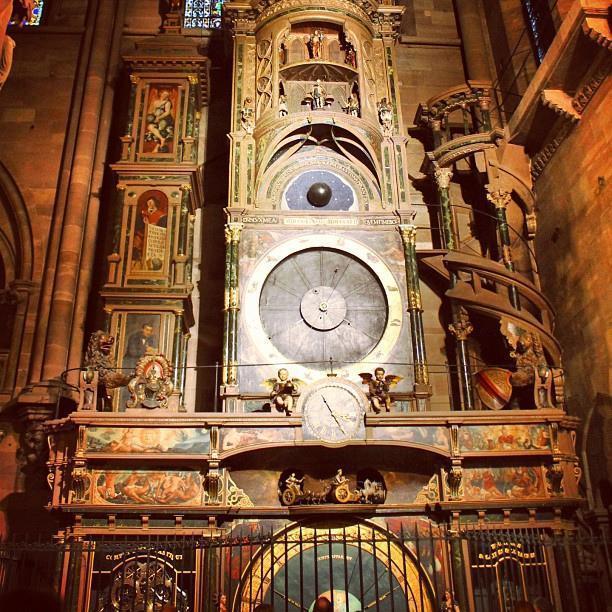How many clocks are in the picture?
Give a very brief answer. 2. 